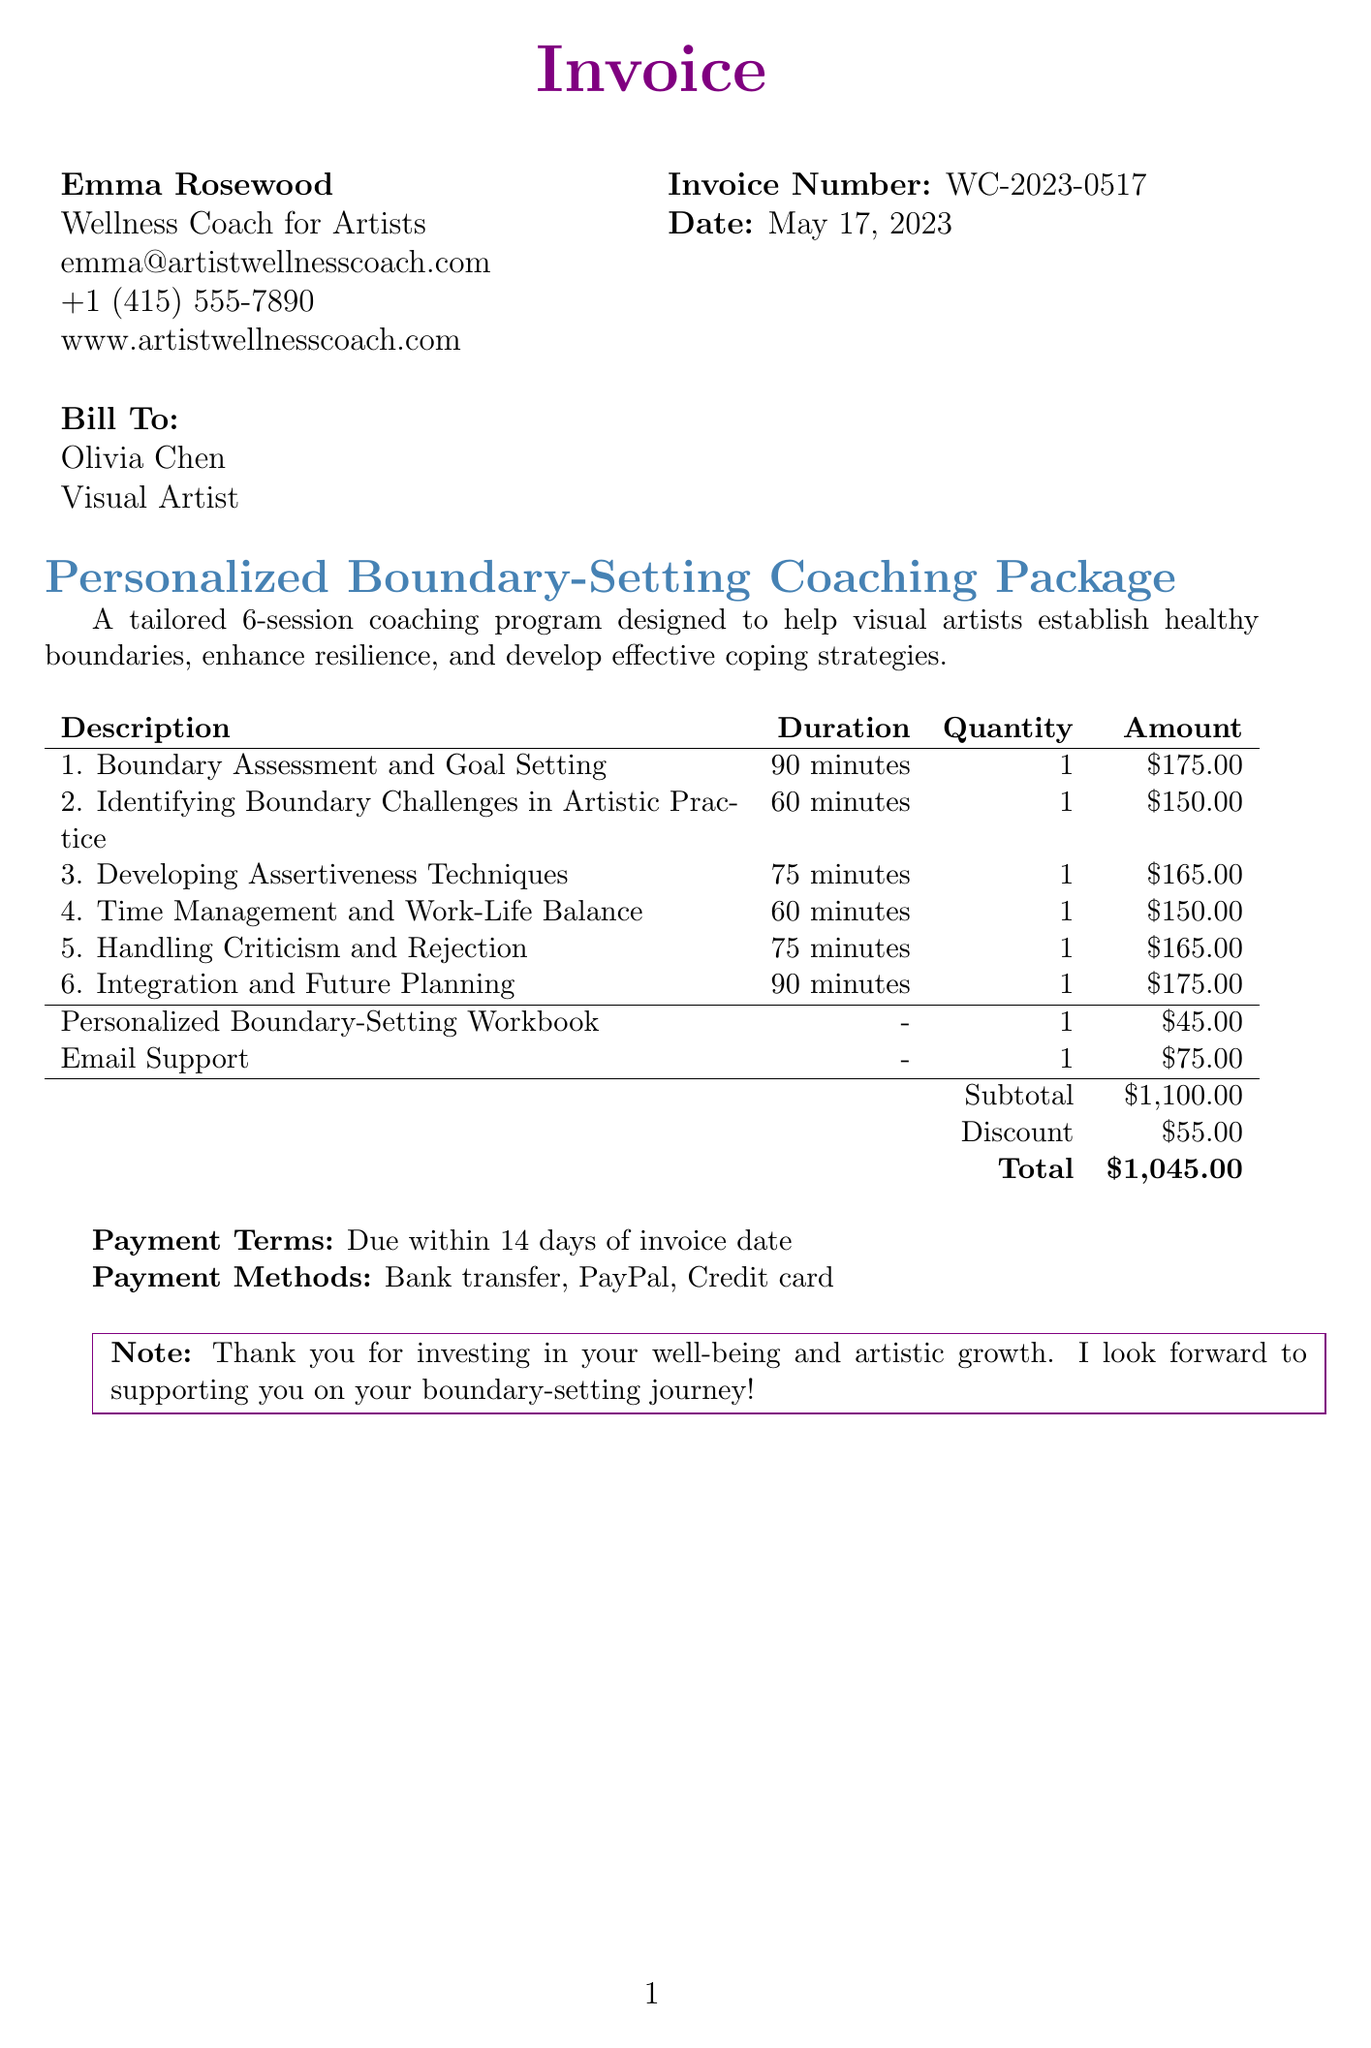What is the invoice number? The invoice number is mentioned at the top of the document.
Answer: WC-2023-0517 Who is the coach? The coach's name appears prominently on the invoice.
Answer: Emma Rosewood What is the total amount due? The total amount is calculated at the end of the invoice details.
Answer: $1,045.00 How many sessions are included in the coaching package? The number of sessions is specified in the description of the package.
Answer: 6 What is the duration of the first session? The duration for each session is listed next to its title.
Answer: 90 minutes What discount was applied to the subtotal? The discount is stated clearly under the subtotal calculations.
Answer: $55.00 What is included in the additional services? The invoice lists additional services with descriptions and costs.
Answer: Personalized Boundary-Setting Workbook, Email Support When is the payment due? The invoice specifies the payment terms at the bottom.
Answer: Due within 14 days of invoice date What payment methods are accepted? Accepted payment methods are listed in the invoice.
Answer: Bank transfer, PayPal, Credit card 